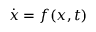Convert formula to latex. <formula><loc_0><loc_0><loc_500><loc_500>\dot { x } = f ( x , t )</formula> 